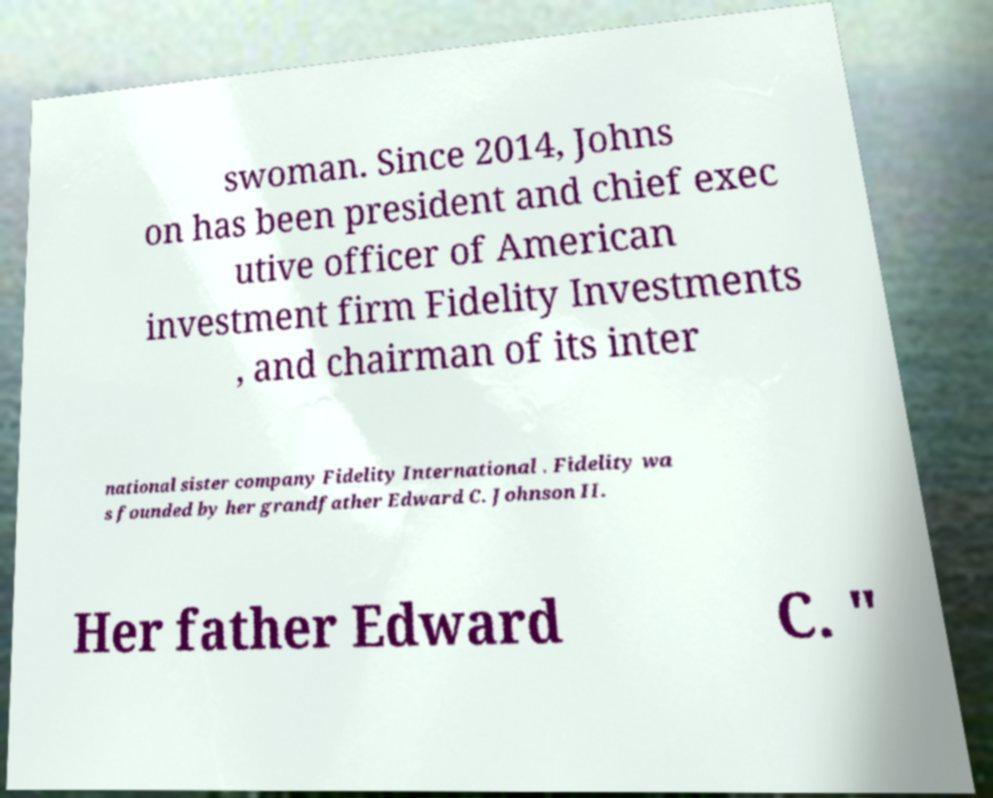Could you assist in decoding the text presented in this image and type it out clearly? swoman. Since 2014, Johns on has been president and chief exec utive officer of American investment firm Fidelity Investments , and chairman of its inter national sister company Fidelity International . Fidelity wa s founded by her grandfather Edward C. Johnson II. Her father Edward C. " 